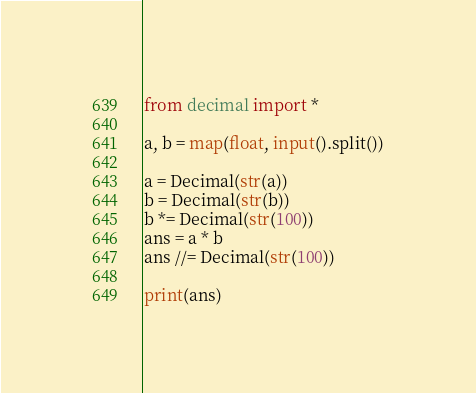Convert code to text. <code><loc_0><loc_0><loc_500><loc_500><_Python_>from decimal import *

a, b = map(float, input().split())

a = Decimal(str(a))
b = Decimal(str(b))
b *= Decimal(str(100))
ans = a * b
ans //= Decimal(str(100))

print(ans)</code> 